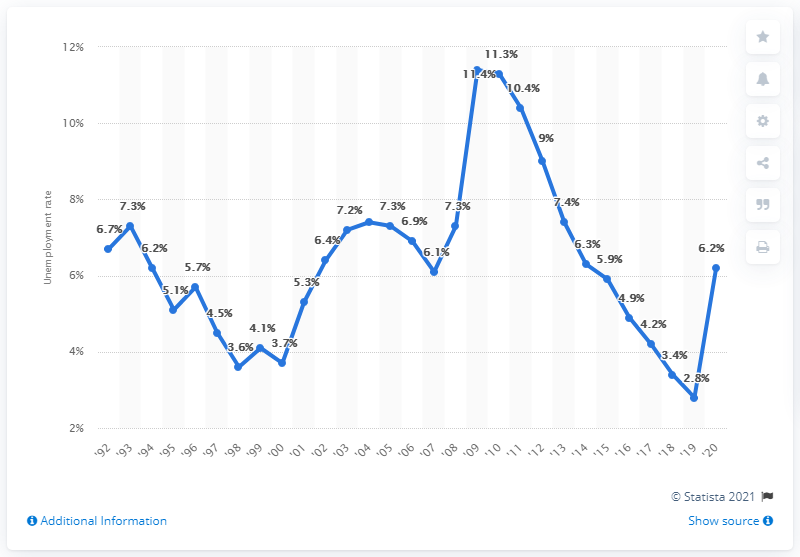Specify some key components in this picture. In 2020, the unemployment rate in South Carolina was 6.2%. 